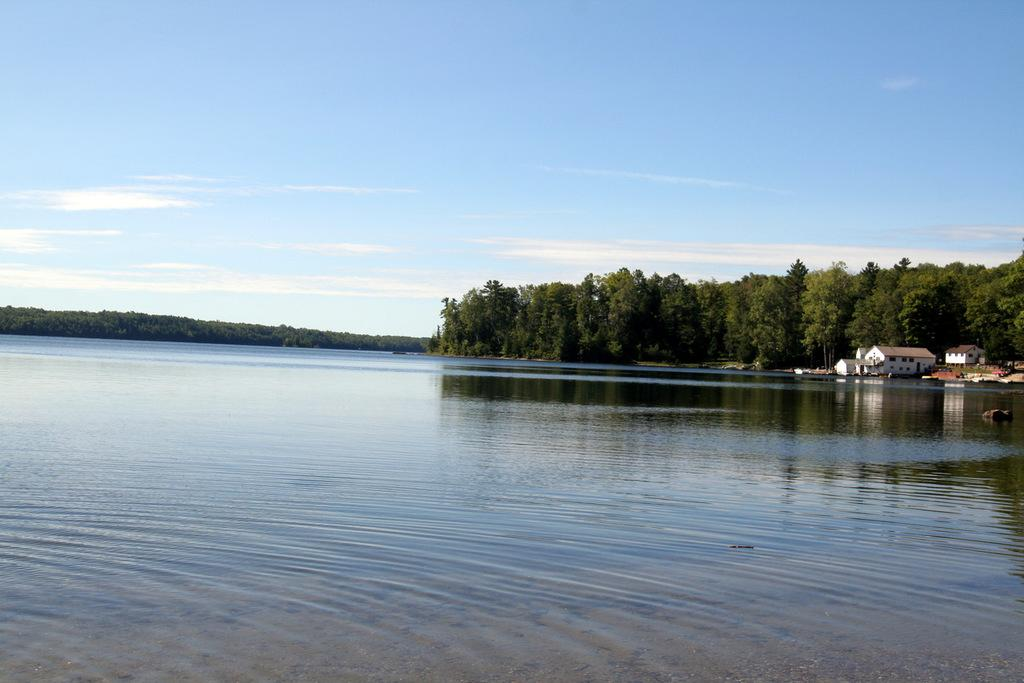What is located in the foreground of the image? There is a water body in the foreground of the image. What can be seen on the right side of the image? There are buildings on the right side of the image. What type of vegetation is in the center of the image? There are trees in the center of the image. What is visible at the top of the image? The sky is visible at the top of the image. Can you see a rabbit playing with a cable in the image? There is no rabbit or cable present in the image. What type of glass object is visible in the image? There is no glass object present in the image. 